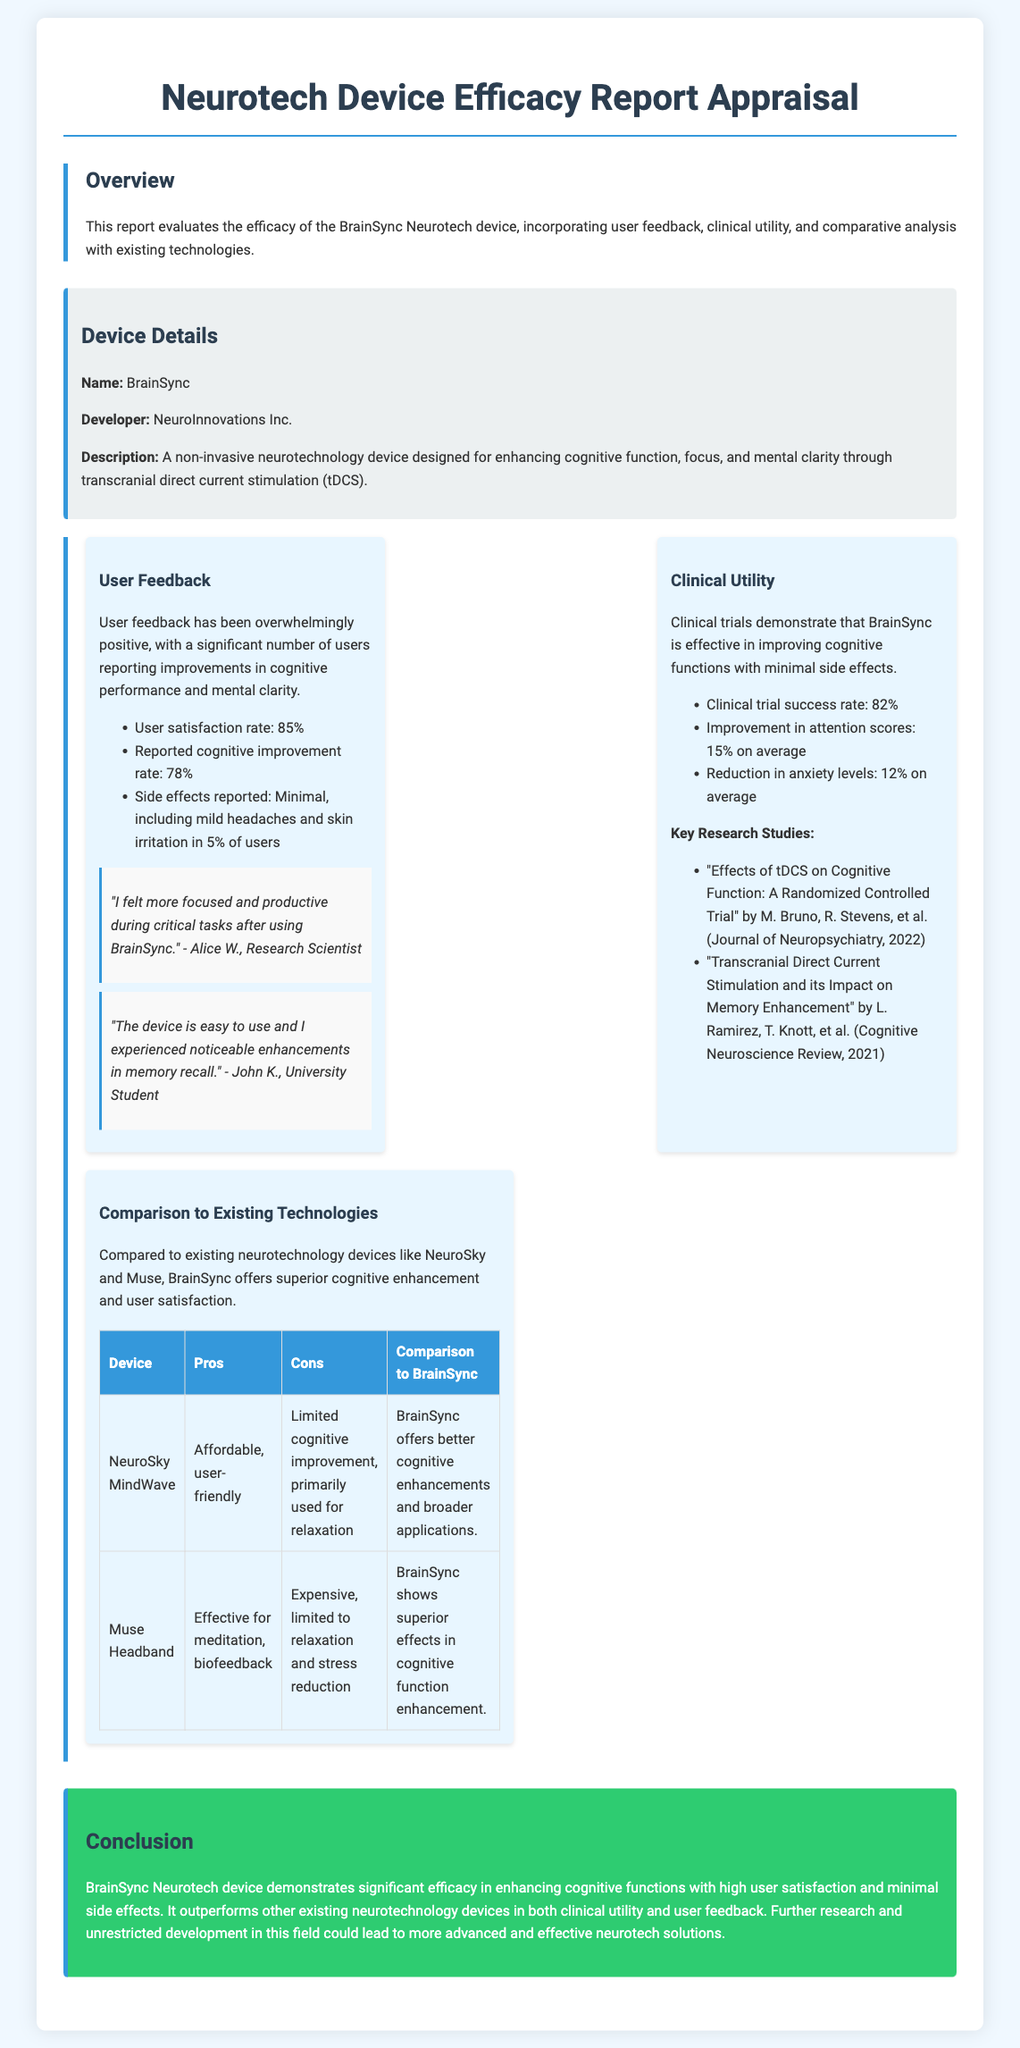What is the name of the neurotechnology device? The name of the device is mentioned in the "Device Details" section, which lists it as "BrainSync."
Answer: BrainSync Who developed the BrainSync device? The developer of BrainSync is provided in the "Device Details" section as "NeuroInnovations Inc."
Answer: NeuroInnovations Inc What is the user satisfaction rate reported in the user feedback? The user satisfaction rate is found under "User Feedback," where it is stated as 85%.
Answer: 85% What is the clinical trial success rate for BrainSync? The clinical trial success rate is highlighted in the "Clinical Utility" section, where it states that it is 82%.
Answer: 82% What are the side effects reported by users? The side effects are listed in the user feedback section, indicating that there are minimal side effects with specific mention of mild headaches and skin irritation.
Answer: Mild headaches and skin irritation How does BrainSync compare to NeuroSky MindWave? The comparison table provides pros, cons, and details on how BrainSync offers better cognitive enhancements, indicating its overall superiority.
Answer: Better cognitive enhancements Which key research study is mentioned in the report? A key study is highlighted in the "Clinical Utility" section, which is titled "Effects of tDCS on Cognitive Function: A Randomized Controlled Trial."
Answer: Effects of tDCS on Cognitive Function: A Randomized Controlled Trial What percentage improvement in attention scores was observed in clinical trials? The document states that there was a 15% average improvement in attention scores in the clinical trials.
Answer: 15% What conclusion is drawn regarding BrainSync's efficacy? The conclusion in the report states that BrainSync demonstrates significant efficacy in enhancing cognitive functions.
Answer: Significant efficacy in enhancing cognitive functions 